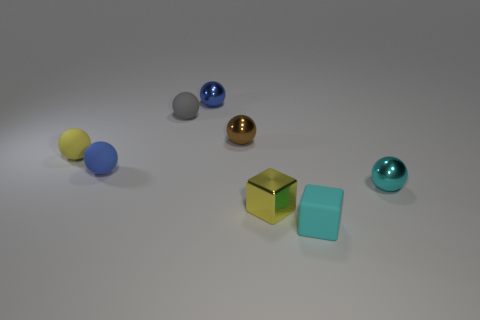Are there any tiny blue shiny things of the same shape as the tiny cyan shiny thing?
Your answer should be compact. Yes. What material is the thing that is the same color as the metal block?
Provide a succinct answer. Rubber. There is a yellow thing that is in front of the metal sphere on the right side of the brown shiny object; what shape is it?
Your response must be concise. Cube. How many blocks are the same material as the small cyan ball?
Ensure brevity in your answer.  1. What is the color of the block that is made of the same material as the brown ball?
Your answer should be very brief. Yellow. There is a yellow object that is in front of the sphere on the right side of the block that is behind the cyan cube; how big is it?
Keep it short and to the point. Small. Are there fewer small cyan shiny objects than tiny red matte cylinders?
Ensure brevity in your answer.  No. What is the color of the rubber object that is the same shape as the tiny yellow metal object?
Give a very brief answer. Cyan. Is there a tiny cyan object left of the blue sphere on the left side of the metallic object behind the brown shiny thing?
Provide a succinct answer. No. Do the brown thing and the gray rubber object have the same shape?
Your answer should be compact. Yes. 